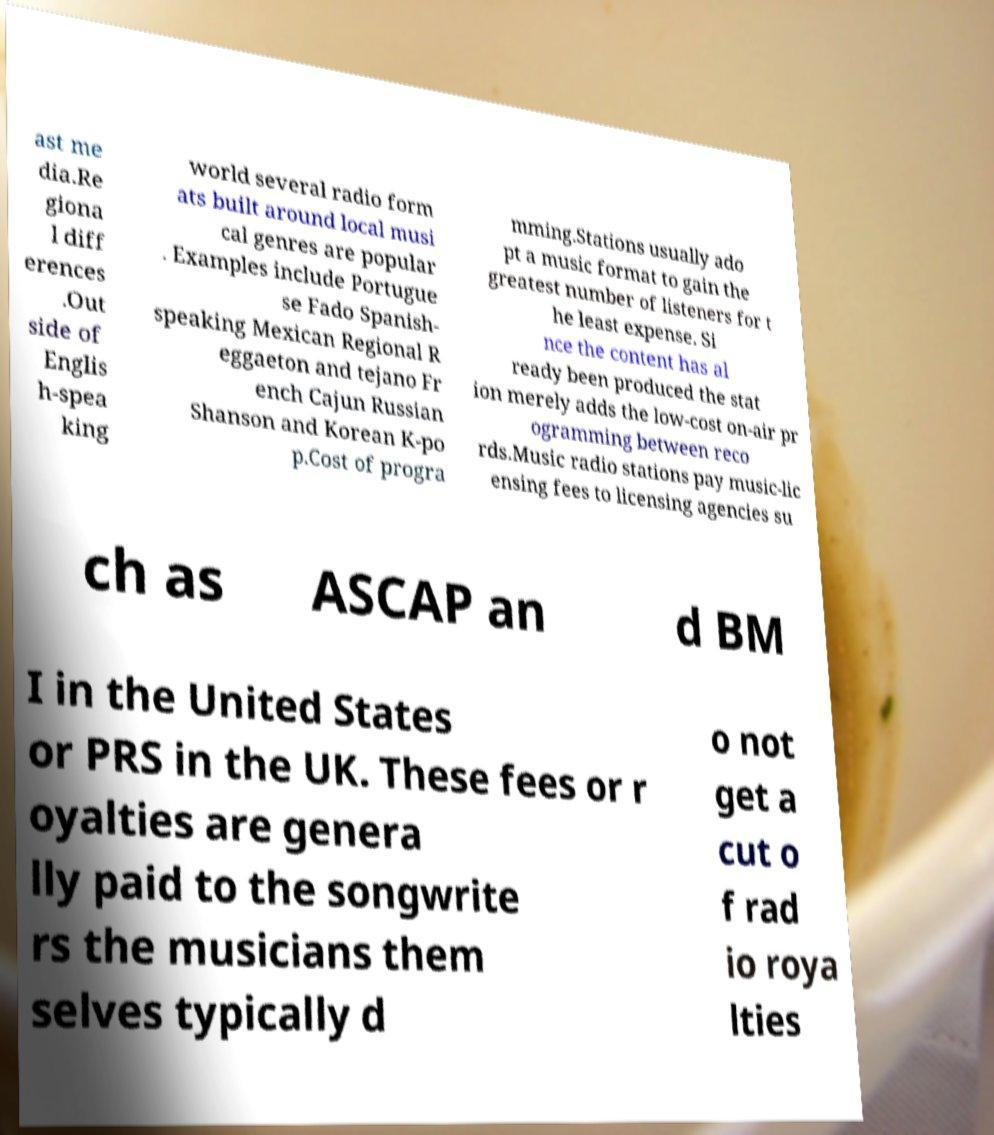For documentation purposes, I need the text within this image transcribed. Could you provide that? ast me dia.Re giona l diff erences .Out side of Englis h-spea king world several radio form ats built around local musi cal genres are popular . Examples include Portugue se Fado Spanish- speaking Mexican Regional R eggaeton and tejano Fr ench Cajun Russian Shanson and Korean K-po p.Cost of progra mming.Stations usually ado pt a music format to gain the greatest number of listeners for t he least expense. Si nce the content has al ready been produced the stat ion merely adds the low-cost on-air pr ogramming between reco rds.Music radio stations pay music-lic ensing fees to licensing agencies su ch as ASCAP an d BM I in the United States or PRS in the UK. These fees or r oyalties are genera lly paid to the songwrite rs the musicians them selves typically d o not get a cut o f rad io roya lties 